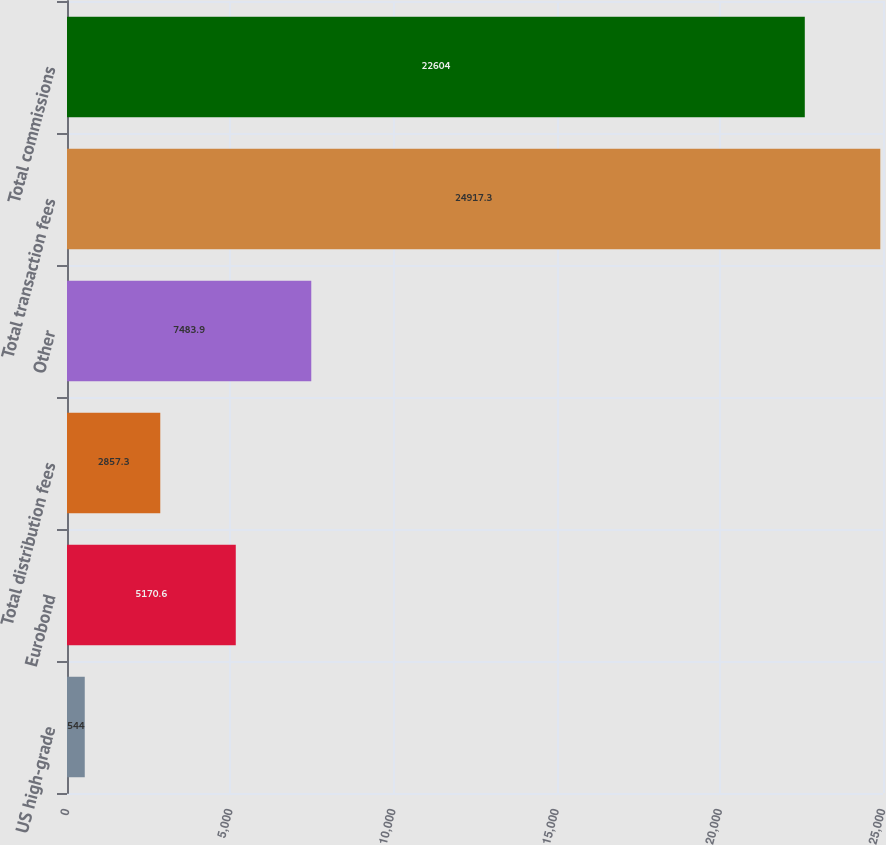<chart> <loc_0><loc_0><loc_500><loc_500><bar_chart><fcel>US high-grade<fcel>Eurobond<fcel>Total distribution fees<fcel>Other<fcel>Total transaction fees<fcel>Total commissions<nl><fcel>544<fcel>5170.6<fcel>2857.3<fcel>7483.9<fcel>24917.3<fcel>22604<nl></chart> 